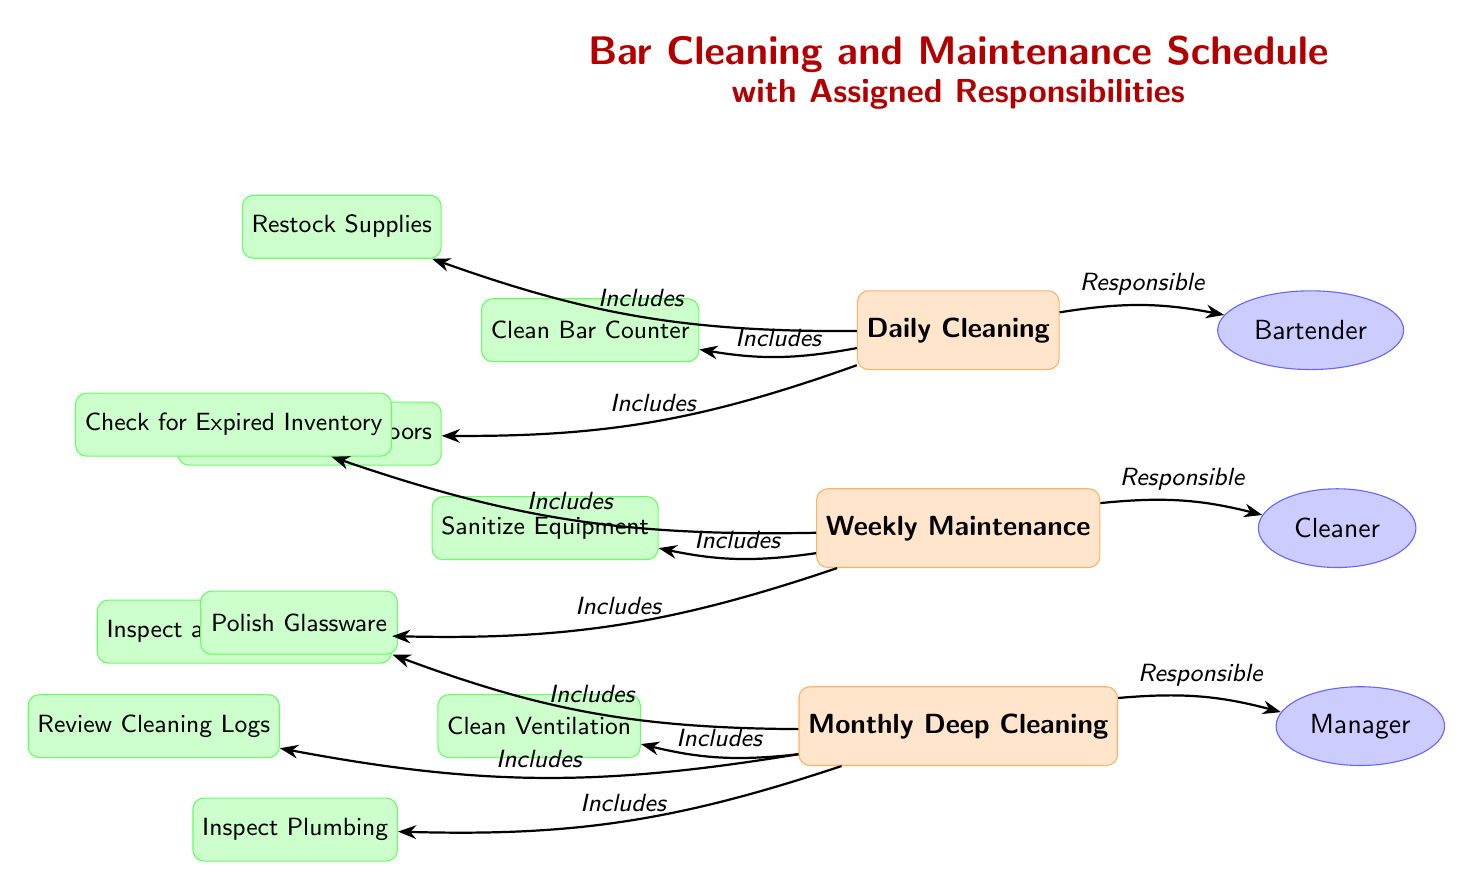What is the first task listed under Daily Cleaning? The diagram shows "Daily Cleaning" at the top, with an arrow indicating that the first task under this category is "Clean Bar Counter".
Answer: Clean Bar Counter Who is responsible for Weekly Maintenance? In the diagram, the "Weekly Maintenance" node has an arrow pointing to the "Cleaner", indicating that this role is responsible for this maintenance schedule.
Answer: Cleaner How many tasks are listed under Monthly Deep Cleaning? The "Monthly Deep Cleaning" node has three tasks linked to it: "Clean Ventilation", "Polish Glassware", and "Inspect Plumbing". Therefore, the total number of tasks is three.
Answer: 3 What is the responsibility assigned for Daily Cleaning? The diagram connects the "Daily Cleaning" node to the "Bartender" node, showing that the bartender is responsible for daily cleaning tasks.
Answer: Bartender Which task is included in both Daily Cleaning and Weekly Maintenance? The diagram distinguishes the tasks under "Daily Cleaning" and "Weekly Maintenance". Upon inspection, it is clear that there is no task that is shared between these two categories.
Answer: None What does the "Manager" oversee according to the diagram? The "Manager" node is linked only to the "Monthly Deep Cleaning", indicating that this role oversees the tasks in this maintenance category.
Answer: Monthly Deep Cleaning What task involves checking for inventory issues? In the "Weekly Maintenance" section, the task "Check for Expired Inventory" addresses inventory issues. This task specifically denotes checking for expired items.
Answer: Check for Expired Inventory Which task directly follows the task "Inspect Plumbing" in the Monthly Deep Cleaning section? The "Inspect Plumbing" task does not have any subsequent tasks listed in the diagram. It is the last task connected to the "Monthly Deep Cleaning" node.
Answer: None Which node is found at the bottom of the diagram? The layout of the diagram shows "Monthly Deep Cleaning" as the last schedule in descending order, placing it at the bottom of the diagram structure.
Answer: Monthly Deep Cleaning 